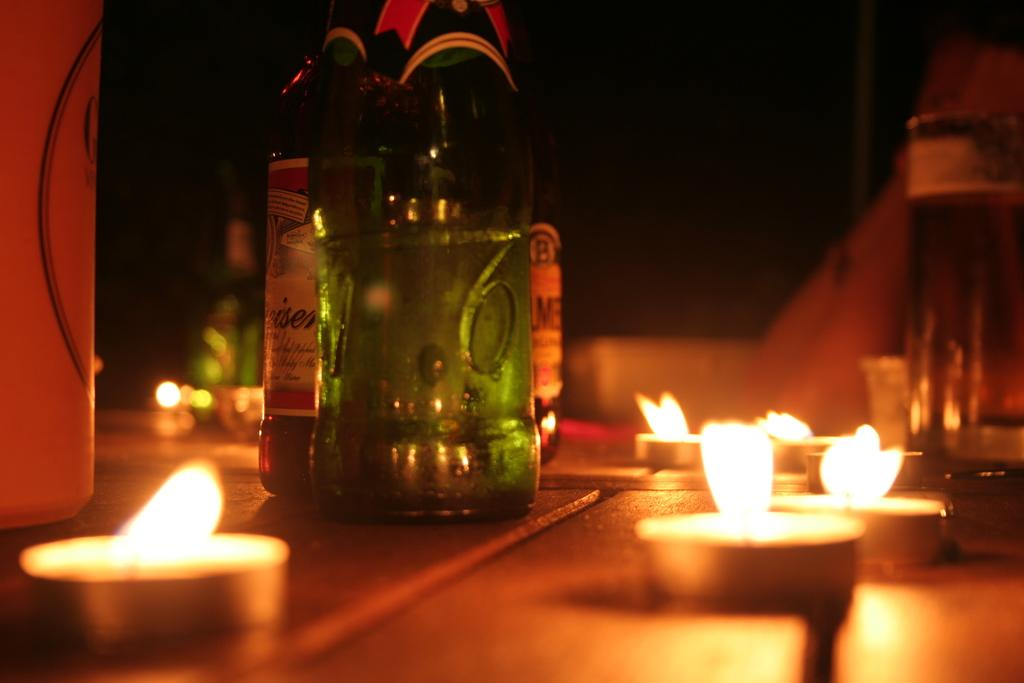What type of small lights are present in the image? There are tea lights in the image. What else can be seen on the path in the image? There are bottles visible on the path. Can you describe the setting of the image? The objects are on a path, and the background of the image is blurred. What type of pies are being served in the image? There are no pies present in the image; it features tea lights and bottles on a path. What caption would you give to the image? It is not possible to provide a caption for the image based on the given facts, as they do not include any context or information about the purpose or meaning of the image. 